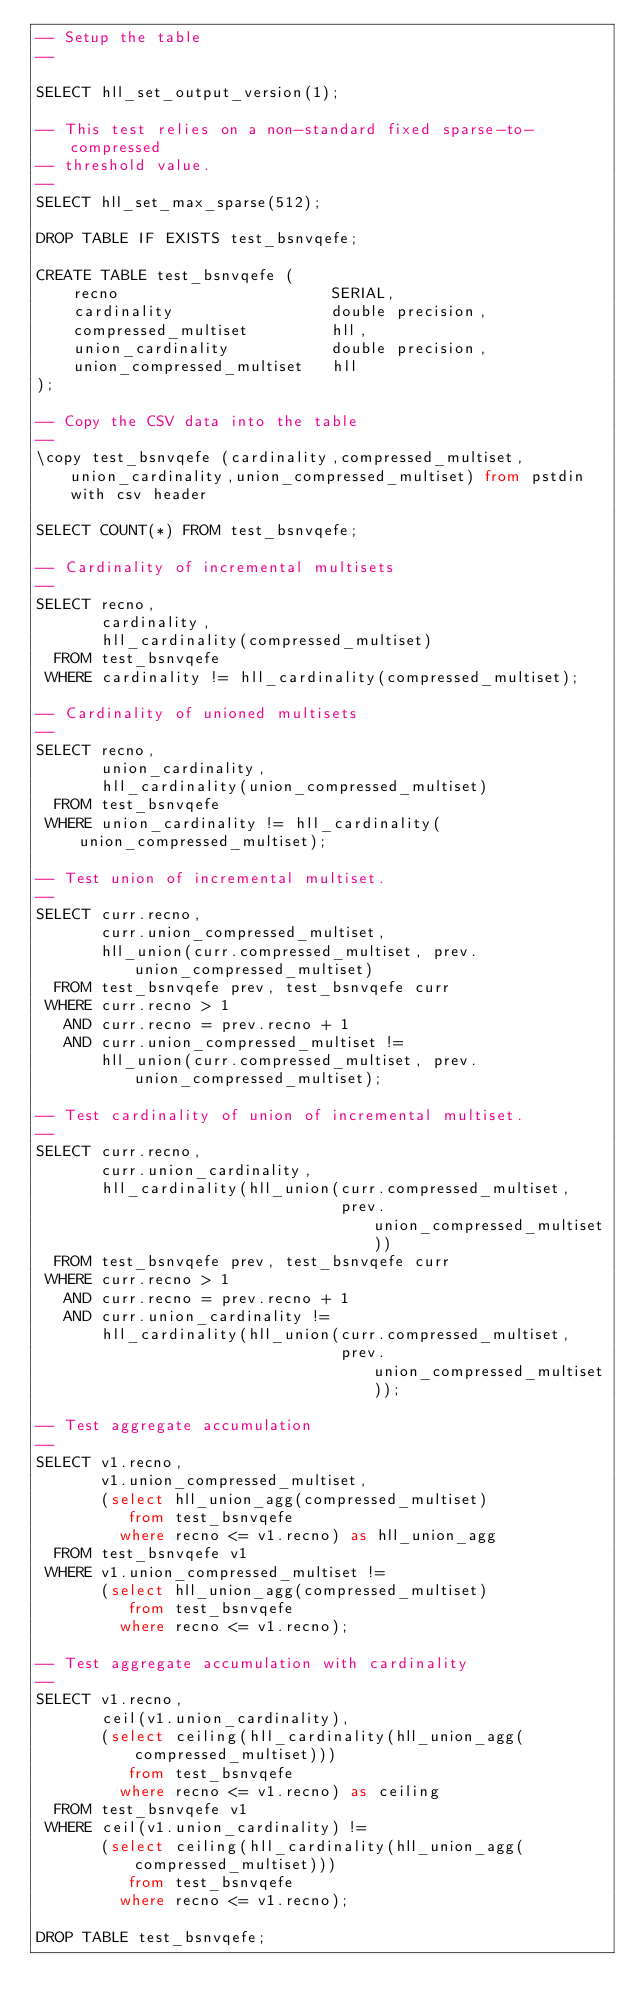<code> <loc_0><loc_0><loc_500><loc_500><_SQL_>-- Setup the table
--

SELECT hll_set_output_version(1);

-- This test relies on a non-standard fixed sparse-to-compressed
-- threshold value.
--
SELECT hll_set_max_sparse(512);

DROP TABLE IF EXISTS test_bsnvqefe;

CREATE TABLE test_bsnvqefe (
    recno                       SERIAL,
    cardinality                 double precision,
    compressed_multiset         hll,
    union_cardinality           double precision,
    union_compressed_multiset   hll
);

-- Copy the CSV data into the table
--
\copy test_bsnvqefe (cardinality,compressed_multiset,union_cardinality,union_compressed_multiset) from pstdin with csv header

SELECT COUNT(*) FROM test_bsnvqefe;

-- Cardinality of incremental multisets
--
SELECT recno,
       cardinality,
       hll_cardinality(compressed_multiset)
  FROM test_bsnvqefe
 WHERE cardinality != hll_cardinality(compressed_multiset);

-- Cardinality of unioned multisets
--
SELECT recno,
       union_cardinality,
       hll_cardinality(union_compressed_multiset)
  FROM test_bsnvqefe
 WHERE union_cardinality != hll_cardinality(union_compressed_multiset);

-- Test union of incremental multiset.
--
SELECT curr.recno,
       curr.union_compressed_multiset,
       hll_union(curr.compressed_multiset, prev.union_compressed_multiset) 
  FROM test_bsnvqefe prev, test_bsnvqefe curr
 WHERE curr.recno > 1
   AND curr.recno = prev.recno + 1
   AND curr.union_compressed_multiset != 
       hll_union(curr.compressed_multiset, prev.union_compressed_multiset);

-- Test cardinality of union of incremental multiset.
--
SELECT curr.recno,
       curr.union_cardinality,
       hll_cardinality(hll_union(curr.compressed_multiset,
                                 prev.union_compressed_multiset))
  FROM test_bsnvqefe prev, test_bsnvqefe curr
 WHERE curr.recno > 1
   AND curr.recno = prev.recno + 1
   AND curr.union_cardinality != 
       hll_cardinality(hll_union(curr.compressed_multiset,
                                 prev.union_compressed_multiset));

-- Test aggregate accumulation
--
SELECT v1.recno,
       v1.union_compressed_multiset,
       (select hll_union_agg(compressed_multiset)
          from test_bsnvqefe
         where recno <= v1.recno) as hll_union_agg
  FROM test_bsnvqefe v1
 WHERE v1.union_compressed_multiset !=
       (select hll_union_agg(compressed_multiset)
          from test_bsnvqefe
         where recno <= v1.recno);

-- Test aggregate accumulation with cardinality
--
SELECT v1.recno,
       ceil(v1.union_cardinality),
       (select ceiling(hll_cardinality(hll_union_agg(compressed_multiset)))
          from test_bsnvqefe
         where recno <= v1.recno) as ceiling
  FROM test_bsnvqefe v1
 WHERE ceil(v1.union_cardinality) !=
       (select ceiling(hll_cardinality(hll_union_agg(compressed_multiset)))
          from test_bsnvqefe
         where recno <= v1.recno);

DROP TABLE test_bsnvqefe;
</code> 